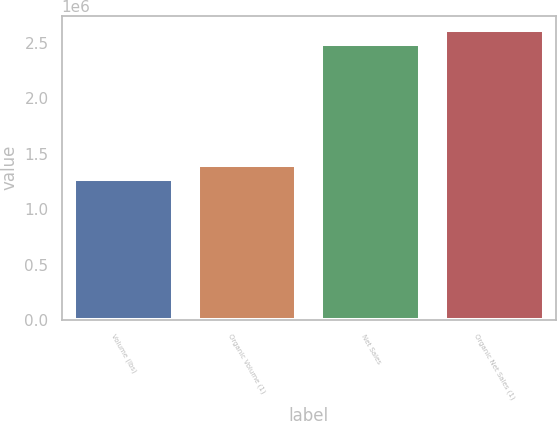Convert chart. <chart><loc_0><loc_0><loc_500><loc_500><bar_chart><fcel>Volume (lbs)<fcel>Organic Volume (1)<fcel>Net Sales<fcel>Organic Net Sales (1)<nl><fcel>1.27527e+06<fcel>1.397e+06<fcel>2.49261e+06<fcel>2.61434e+06<nl></chart> 